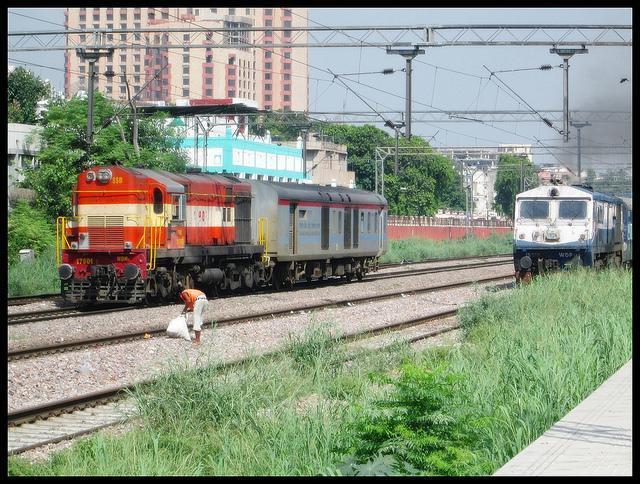How many trains are in the photo?
Give a very brief answer. 2. 